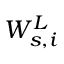<formula> <loc_0><loc_0><loc_500><loc_500>W _ { s , i } ^ { L }</formula> 